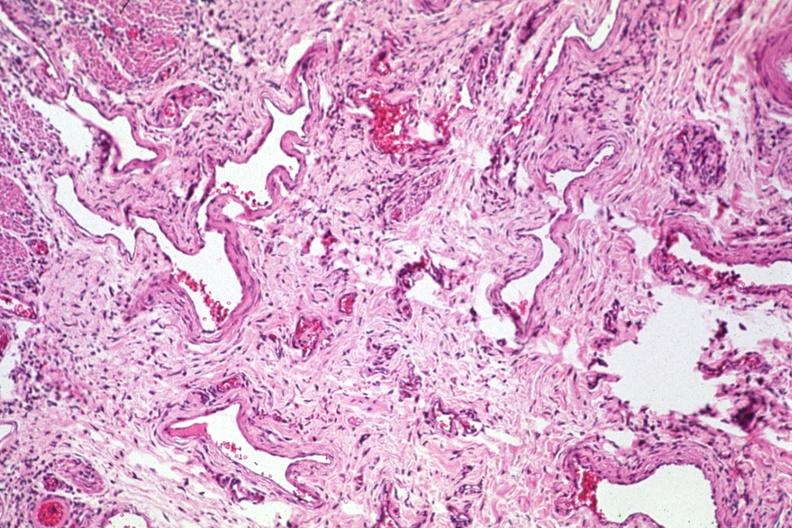s varices present?
Answer the question using a single word or phrase. Yes 